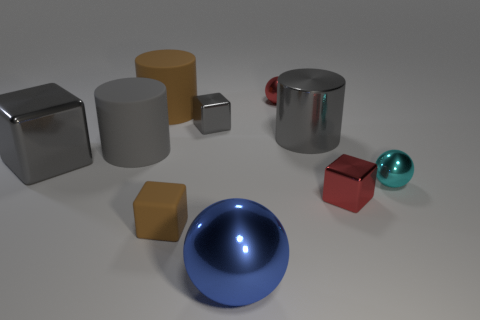How do the surfaces of these objects differ? The objects exhibit a variety of surfaces: there are glossy ones that reflect light and surroundings, like the blue sphere and the silver cylinder; matte ones that absorb more light, such as the gray and brown cylinders; and reflective surfaces with a metallic sheen, noticeable on the silver cube. Each surface interacts with light distinctively, contributing to the overall diverse appearance. 